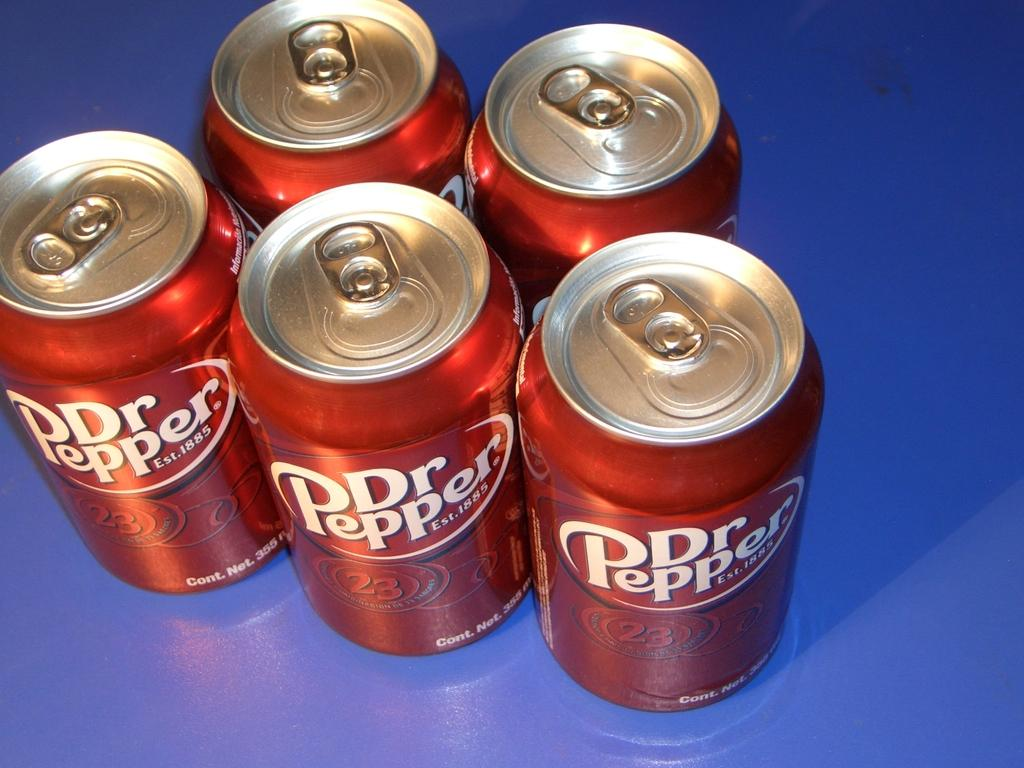<image>
Offer a succinct explanation of the picture presented. Five, Dr Pepper cans of soda that is delicious to drink. 